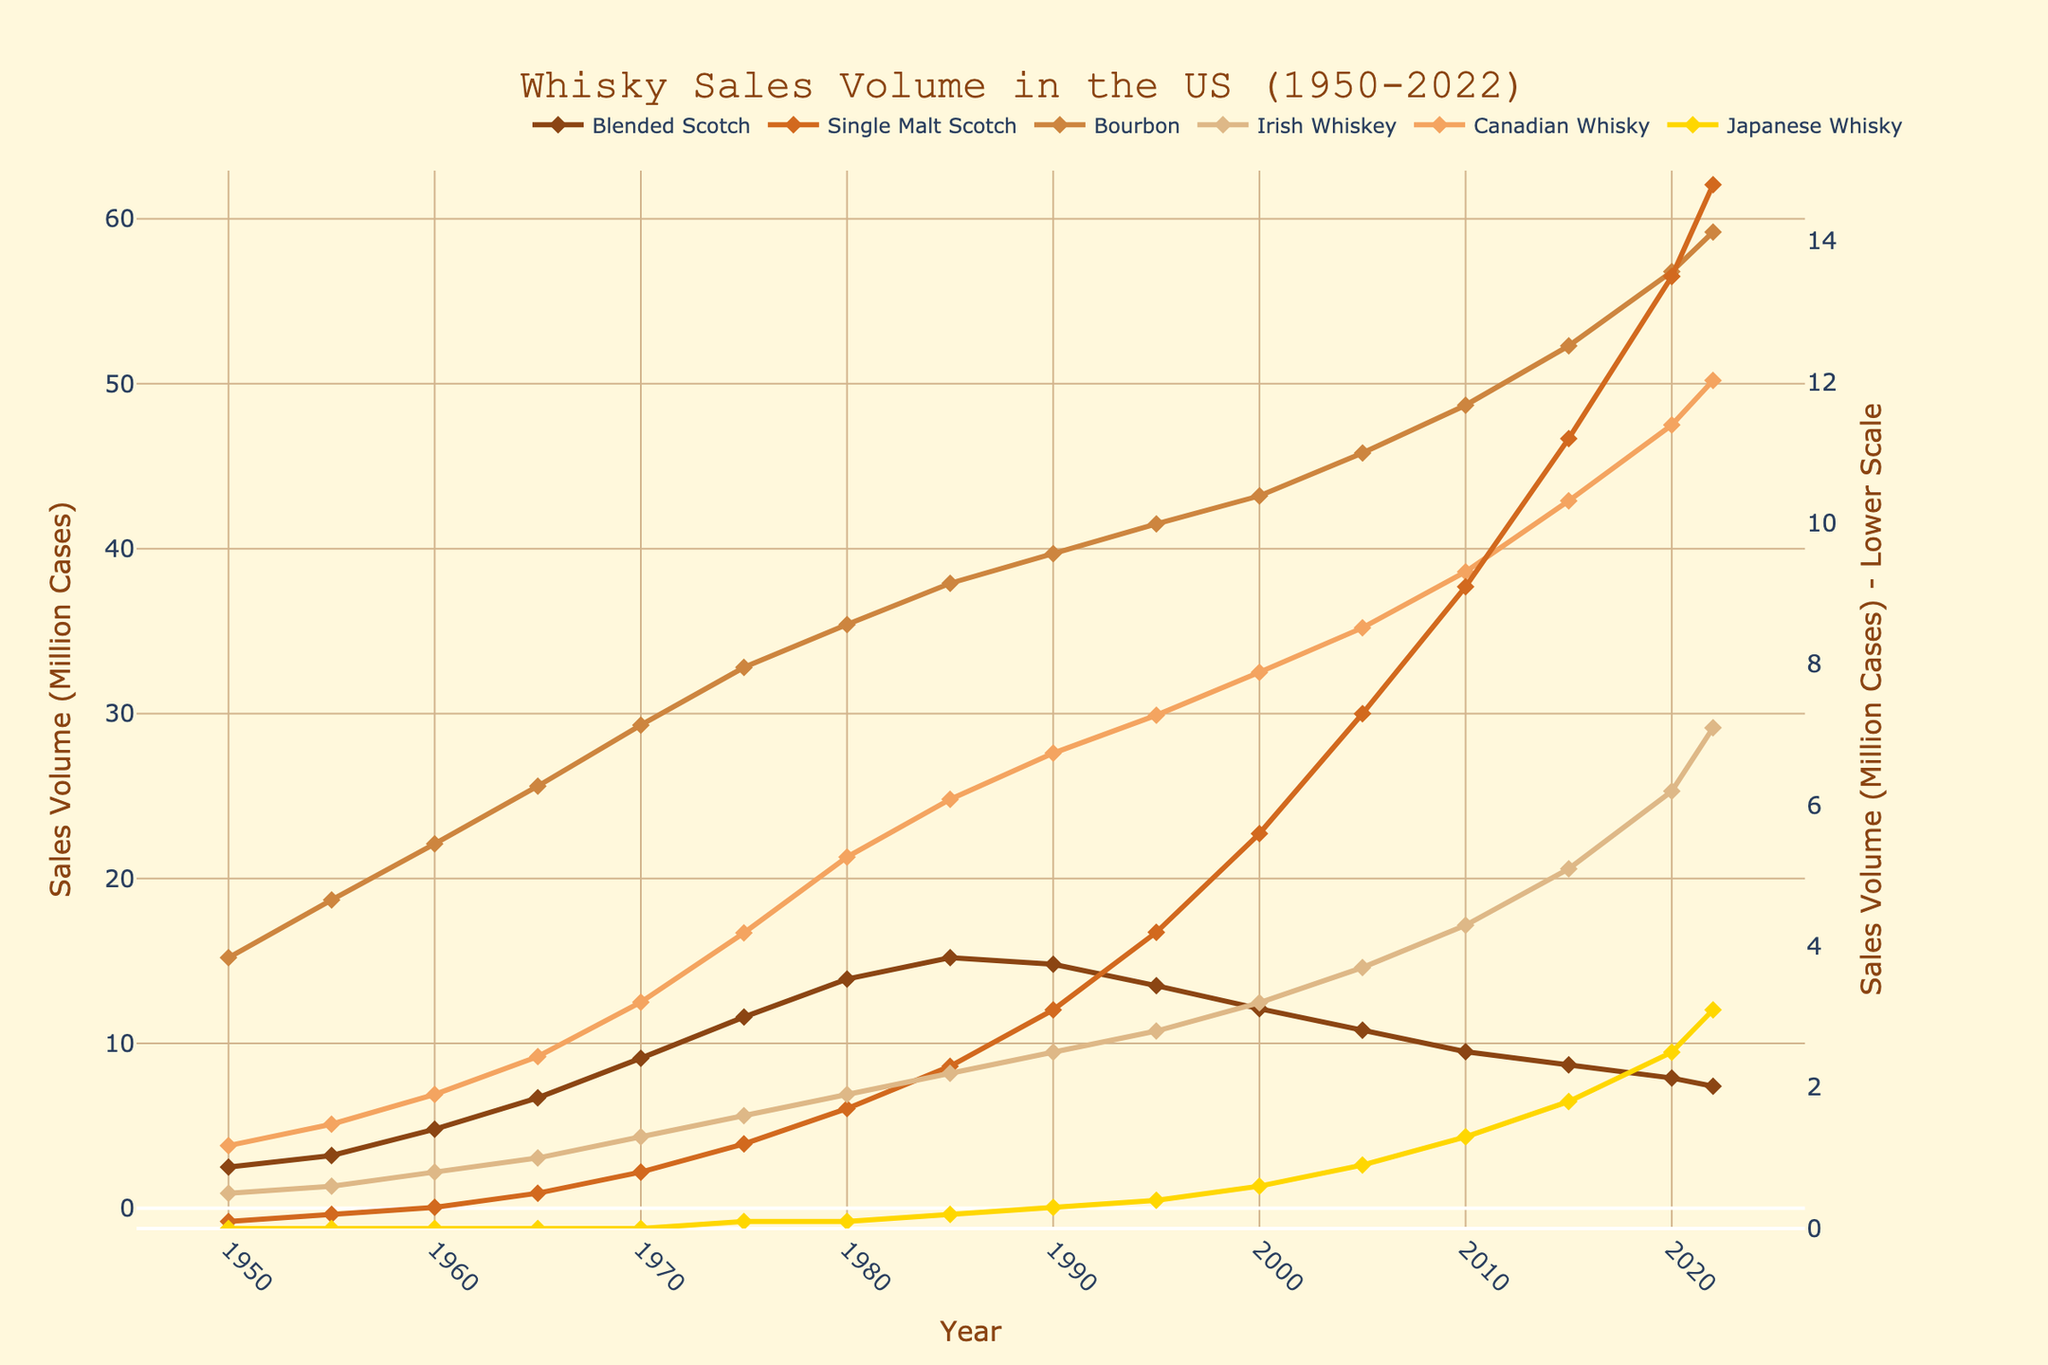What is the general trend of Bourbon sales from 1950 to 2022? To answer this, observe the line representing Bourbon. It consistently ascends from 15.2 million cases in 1950 to 59.2 million cases in 2022, indicating an increasing trend over the years.
Answer: Increasing Which whisky style had the highest sales volume in 2022? By comparing the heights of all lines at the year 2022, Bourbon’s line is the highest, reaching 59.2 million cases. This means Bourbon had the highest sales volume in 2022.
Answer: Bourbon In 1970, how did Blended Scotch sales compare to Canadian Whisky sales? In 1970, observe both lines at this year. Blended Scotch is at 9.1 million cases, while Canadian Whisky is at 12.5 million cases. Canadian Whisky sales were higher than Blended Scotch.
Answer: Canadian Whisky sales were higher Did Japanese Whisky ever surpass Irish Whiskey in sales? Track the lines for Japanese Whisky and Irish Whiskey over the years. The Japanese Whisky line never goes above the Irish Whiskey line, so Japanese Whisky sales never surpassed Irish Whiskey.
Answer: No Which whisky style had the steepest growth in sales between 1950 and 2022? Compare the slopes of the lines. Bourbon has the steepest slope, increasing from 15.2 million cases to 59.2 million cases. Thus, Bourbon had the steepest growth.
Answer: Bourbon How did the sales volume of Single Malt Scotch change from 1950 to 2020? Look at the Single Malt Scotch line at 1950 and 2020. It increased from 0.1 million cases in 1950 to 13.5 million cases in 2020, indicating a significant rise.
Answer: Increased What is the difference in sales volume of Canadian Whisky between 1980 and 1990? Locate the Canadian Whisky line at 1980 (21.3 million cases) and at 1990 (27.6 million cases). The difference is 27.6 - 21.3 = 6.3 million cases.
Answer: 6.3 million cases By how much did Irish Whiskey sales increase from 2000 to 2015? Irish Whiskey sales increased from 3.2 million cases in 2000 to 5.1 million cases in 2015. The increase is 5.1 - 3.2 = 1.9 million cases.
Answer: 1.9 million cases What is the overall trend for Blended Scotch sales from 1950 to 2022, and how does it compare to Single Malt Scotch sales? Blended Scotch generally shows a rise, peaking around 1990 and then slightly declining. Single Malt Scotch shows a steady increase throughout. Thus, Blended Scotch’s trend is cyclic, while Single Malt Scotch’s trend is consistently increasing.
Answer: Blended Scotch: cyclic, Single Malt Scotch: increasing What is the maximum sales volume recorded for Bourbon, and in which year did it occur? Identify the highest point on the Bourbon line. The maximum sales volume recorded is 59.2 million cases, occurring in 2022.
Answer: 59.2 million cases in 2022 